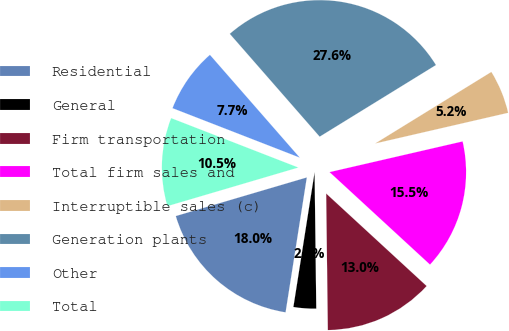Convert chart to OTSL. <chart><loc_0><loc_0><loc_500><loc_500><pie_chart><fcel>Residential<fcel>General<fcel>Firm transportation<fcel>Total firm sales and<fcel>Interruptible sales (c)<fcel>Generation plants<fcel>Other<fcel>Total<nl><fcel>17.95%<fcel>2.68%<fcel>12.96%<fcel>15.45%<fcel>5.18%<fcel>27.64%<fcel>7.67%<fcel>10.46%<nl></chart> 